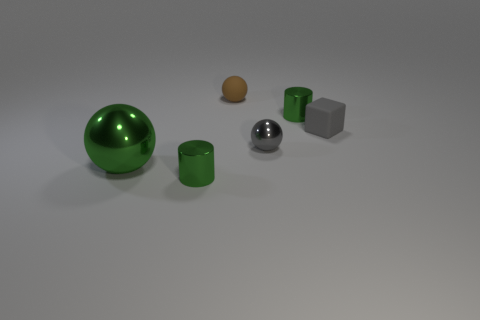There is a gray thing that is the same size as the cube; what is its shape?
Your response must be concise. Sphere. How many other things are there of the same color as the large metallic ball?
Your answer should be compact. 2. What color is the tiny cylinder behind the small gray metallic thing?
Provide a succinct answer. Green. How many other things are there of the same material as the big green object?
Your response must be concise. 3. Are there more big metal objects that are behind the small shiny sphere than small gray rubber things that are in front of the small gray rubber object?
Ensure brevity in your answer.  No. There is a gray shiny ball; what number of tiny green objects are on the right side of it?
Give a very brief answer. 1. Do the cube and the large ball in front of the brown object have the same material?
Offer a terse response. No. Is there any other thing that is the same shape as the brown object?
Offer a terse response. Yes. Does the big ball have the same material as the brown sphere?
Your answer should be compact. No. Are there any green metallic cylinders that are to the left of the green cylinder that is on the left side of the tiny metallic ball?
Offer a very short reply. No. 